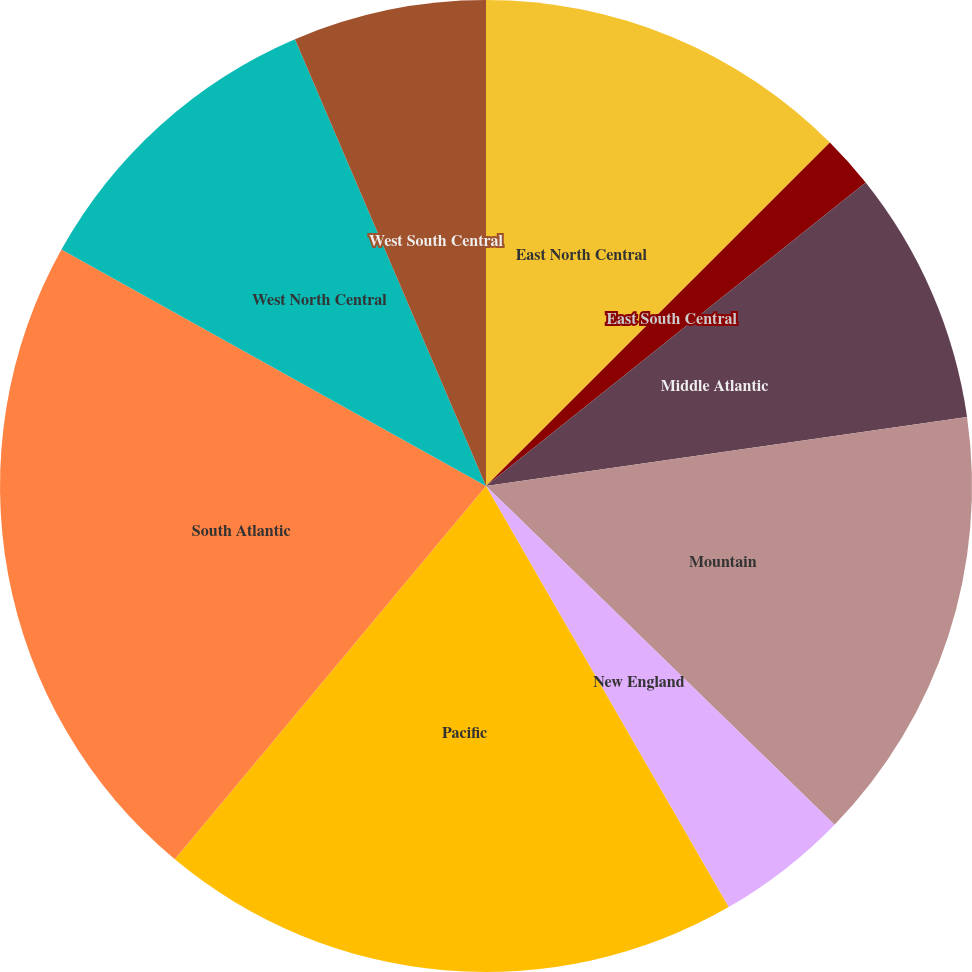<chart> <loc_0><loc_0><loc_500><loc_500><pie_chart><fcel>East North Central<fcel>East South Central<fcel>Middle Atlantic<fcel>Mountain<fcel>New England<fcel>Pacific<fcel>South Atlantic<fcel>West North Central<fcel>West South Central<nl><fcel>12.51%<fcel>1.76%<fcel>8.46%<fcel>14.54%<fcel>4.41%<fcel>19.38%<fcel>22.03%<fcel>10.48%<fcel>6.43%<nl></chart> 